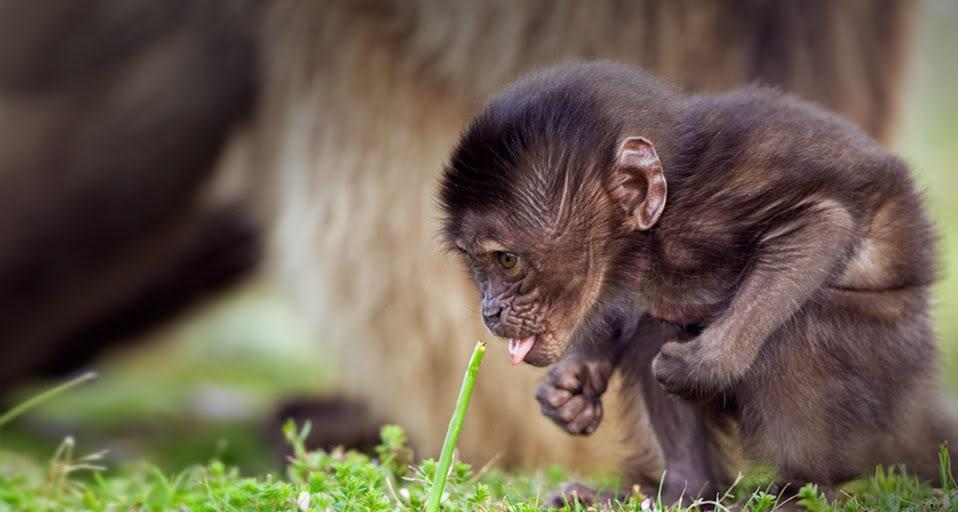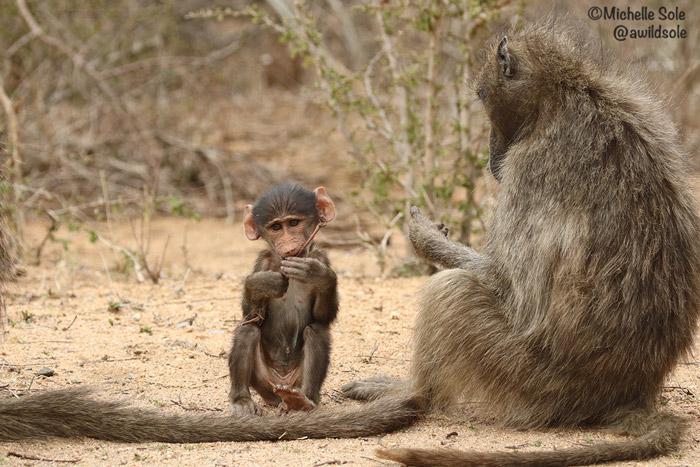The first image is the image on the left, the second image is the image on the right. Examine the images to the left and right. Is the description "There is a baby monkey in each image." accurate? Answer yes or no. Yes. The first image is the image on the left, the second image is the image on the right. For the images shown, is this caption "All images include a baby baboon, and one image clearly shows a baby baboon with an adult baboon." true? Answer yes or no. Yes. 